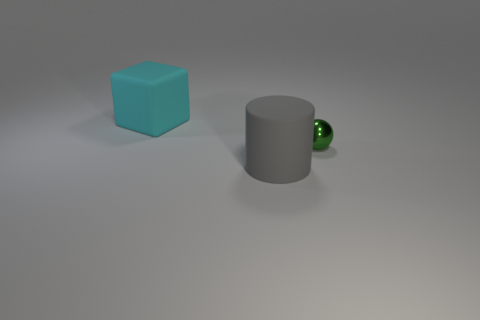Add 2 gray cubes. How many objects exist? 5 Add 3 tiny gray matte balls. How many tiny gray matte balls exist? 3 Subtract 1 gray cylinders. How many objects are left? 2 Subtract all cubes. How many objects are left? 2 Subtract 1 cylinders. How many cylinders are left? 0 Subtract all purple cylinders. How many brown spheres are left? 0 Subtract all small balls. Subtract all big blocks. How many objects are left? 1 Add 3 rubber cubes. How many rubber cubes are left? 4 